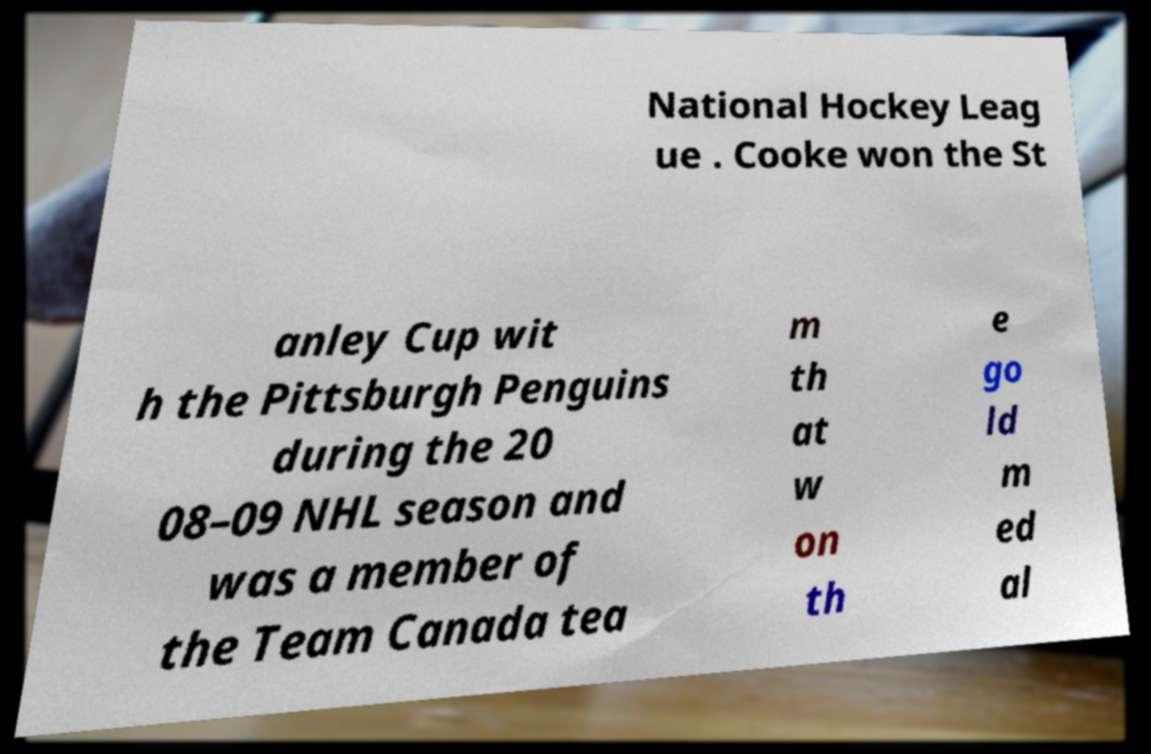Can you accurately transcribe the text from the provided image for me? National Hockey Leag ue . Cooke won the St anley Cup wit h the Pittsburgh Penguins during the 20 08–09 NHL season and was a member of the Team Canada tea m th at w on th e go ld m ed al 